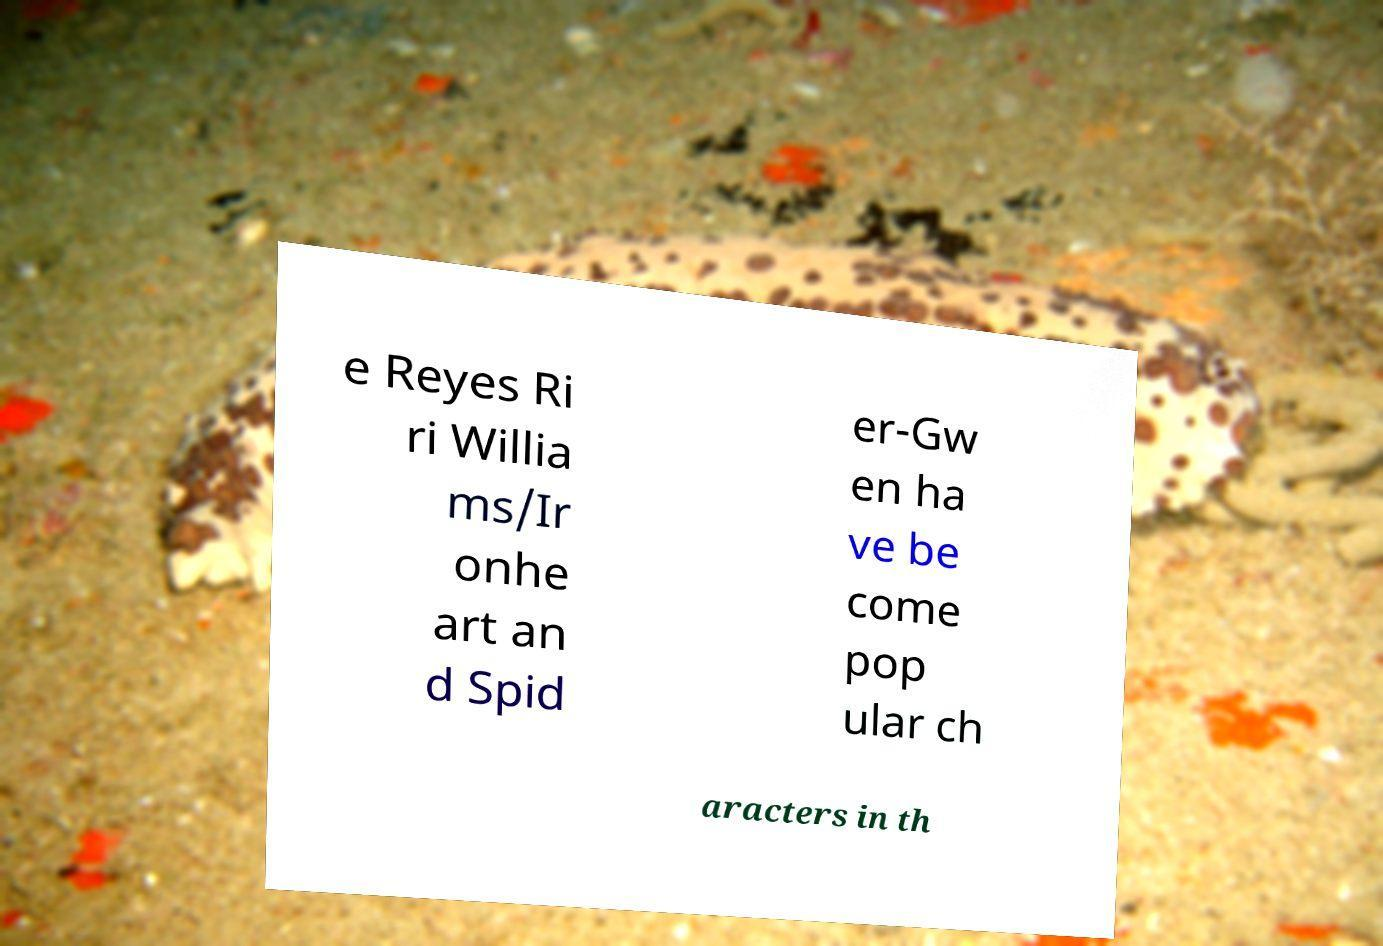What messages or text are displayed in this image? I need them in a readable, typed format. e Reyes Ri ri Willia ms/Ir onhe art an d Spid er-Gw en ha ve be come pop ular ch aracters in th 